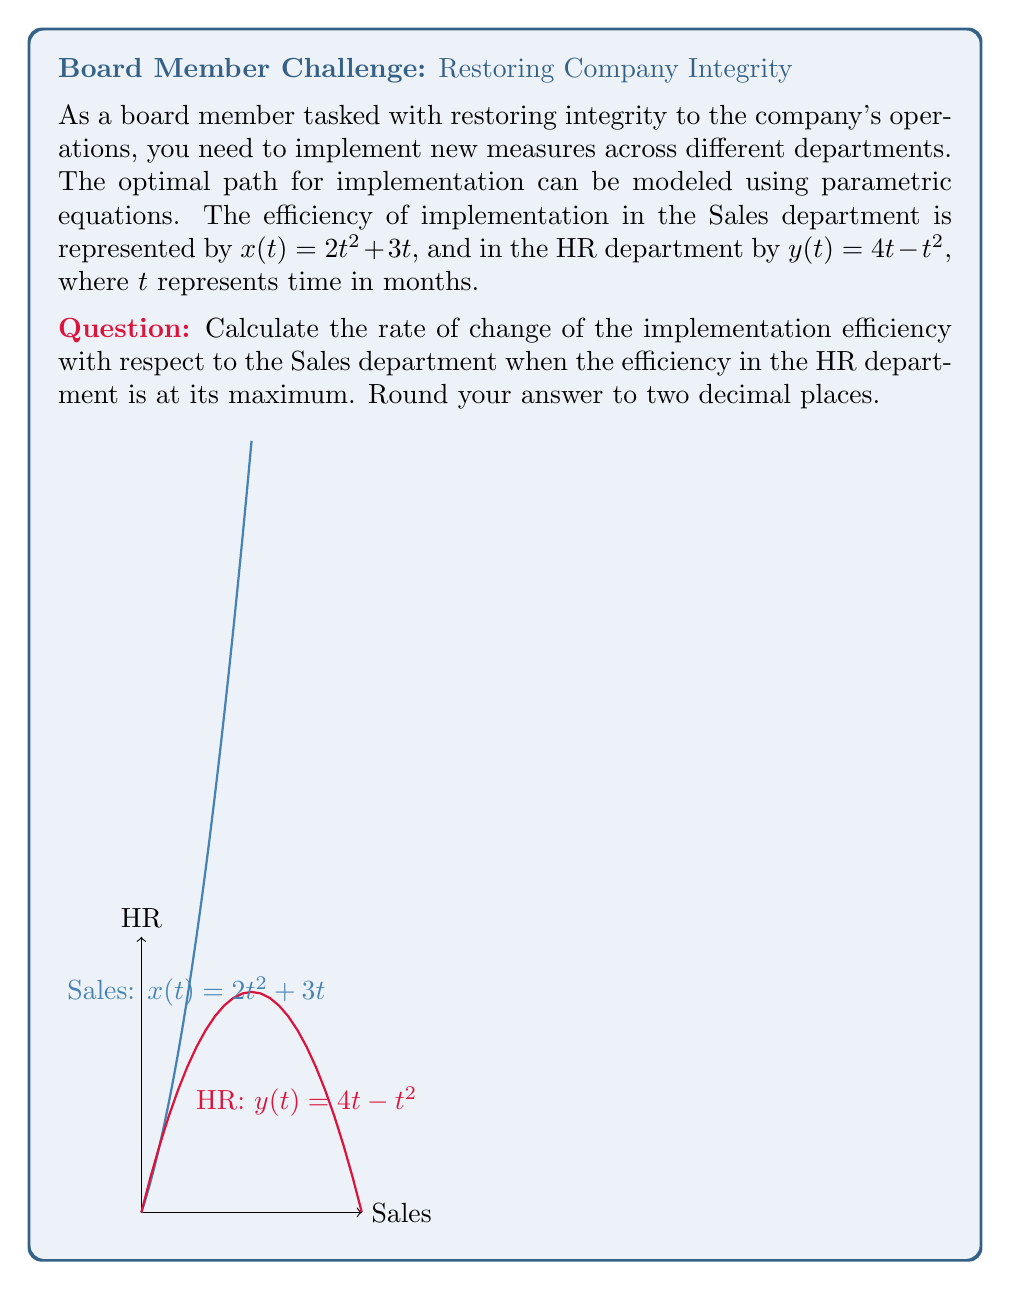Can you solve this math problem? Let's approach this step-by-step:

1) First, we need to find when the efficiency in the HR department is at its maximum. The equation for HR is $y(t) = 4t - t^2$.

2) To find the maximum, we differentiate y with respect to t and set it to zero:
   $$\frac{dy}{dt} = 4 - 2t = 0$$
   $$4 - 2t = 0$$
   $$-2t = -4$$
   $$t = 2$$

3) We can confirm this is a maximum by checking the second derivative is negative:
   $$\frac{d^2y}{dt^2} = -2 < 0$$

4) Now that we know the maximum occurs at $t = 2$, we need to find the rate of change in the Sales department at this time.

5) The equation for Sales is $x(t) = 2t^2 + 3t$. We need to find $\frac{dx}{dt}$ when $t = 2$:
   $$\frac{dx}{dt} = 4t + 3$$

6) Substituting $t = 2$:
   $$\frac{dx}{dt} = 4(2) + 3 = 11$$

7) Therefore, the rate of change of implementation efficiency with respect to the Sales department when HR efficiency is at its maximum is 11 units per month.
Answer: 11 units/month 